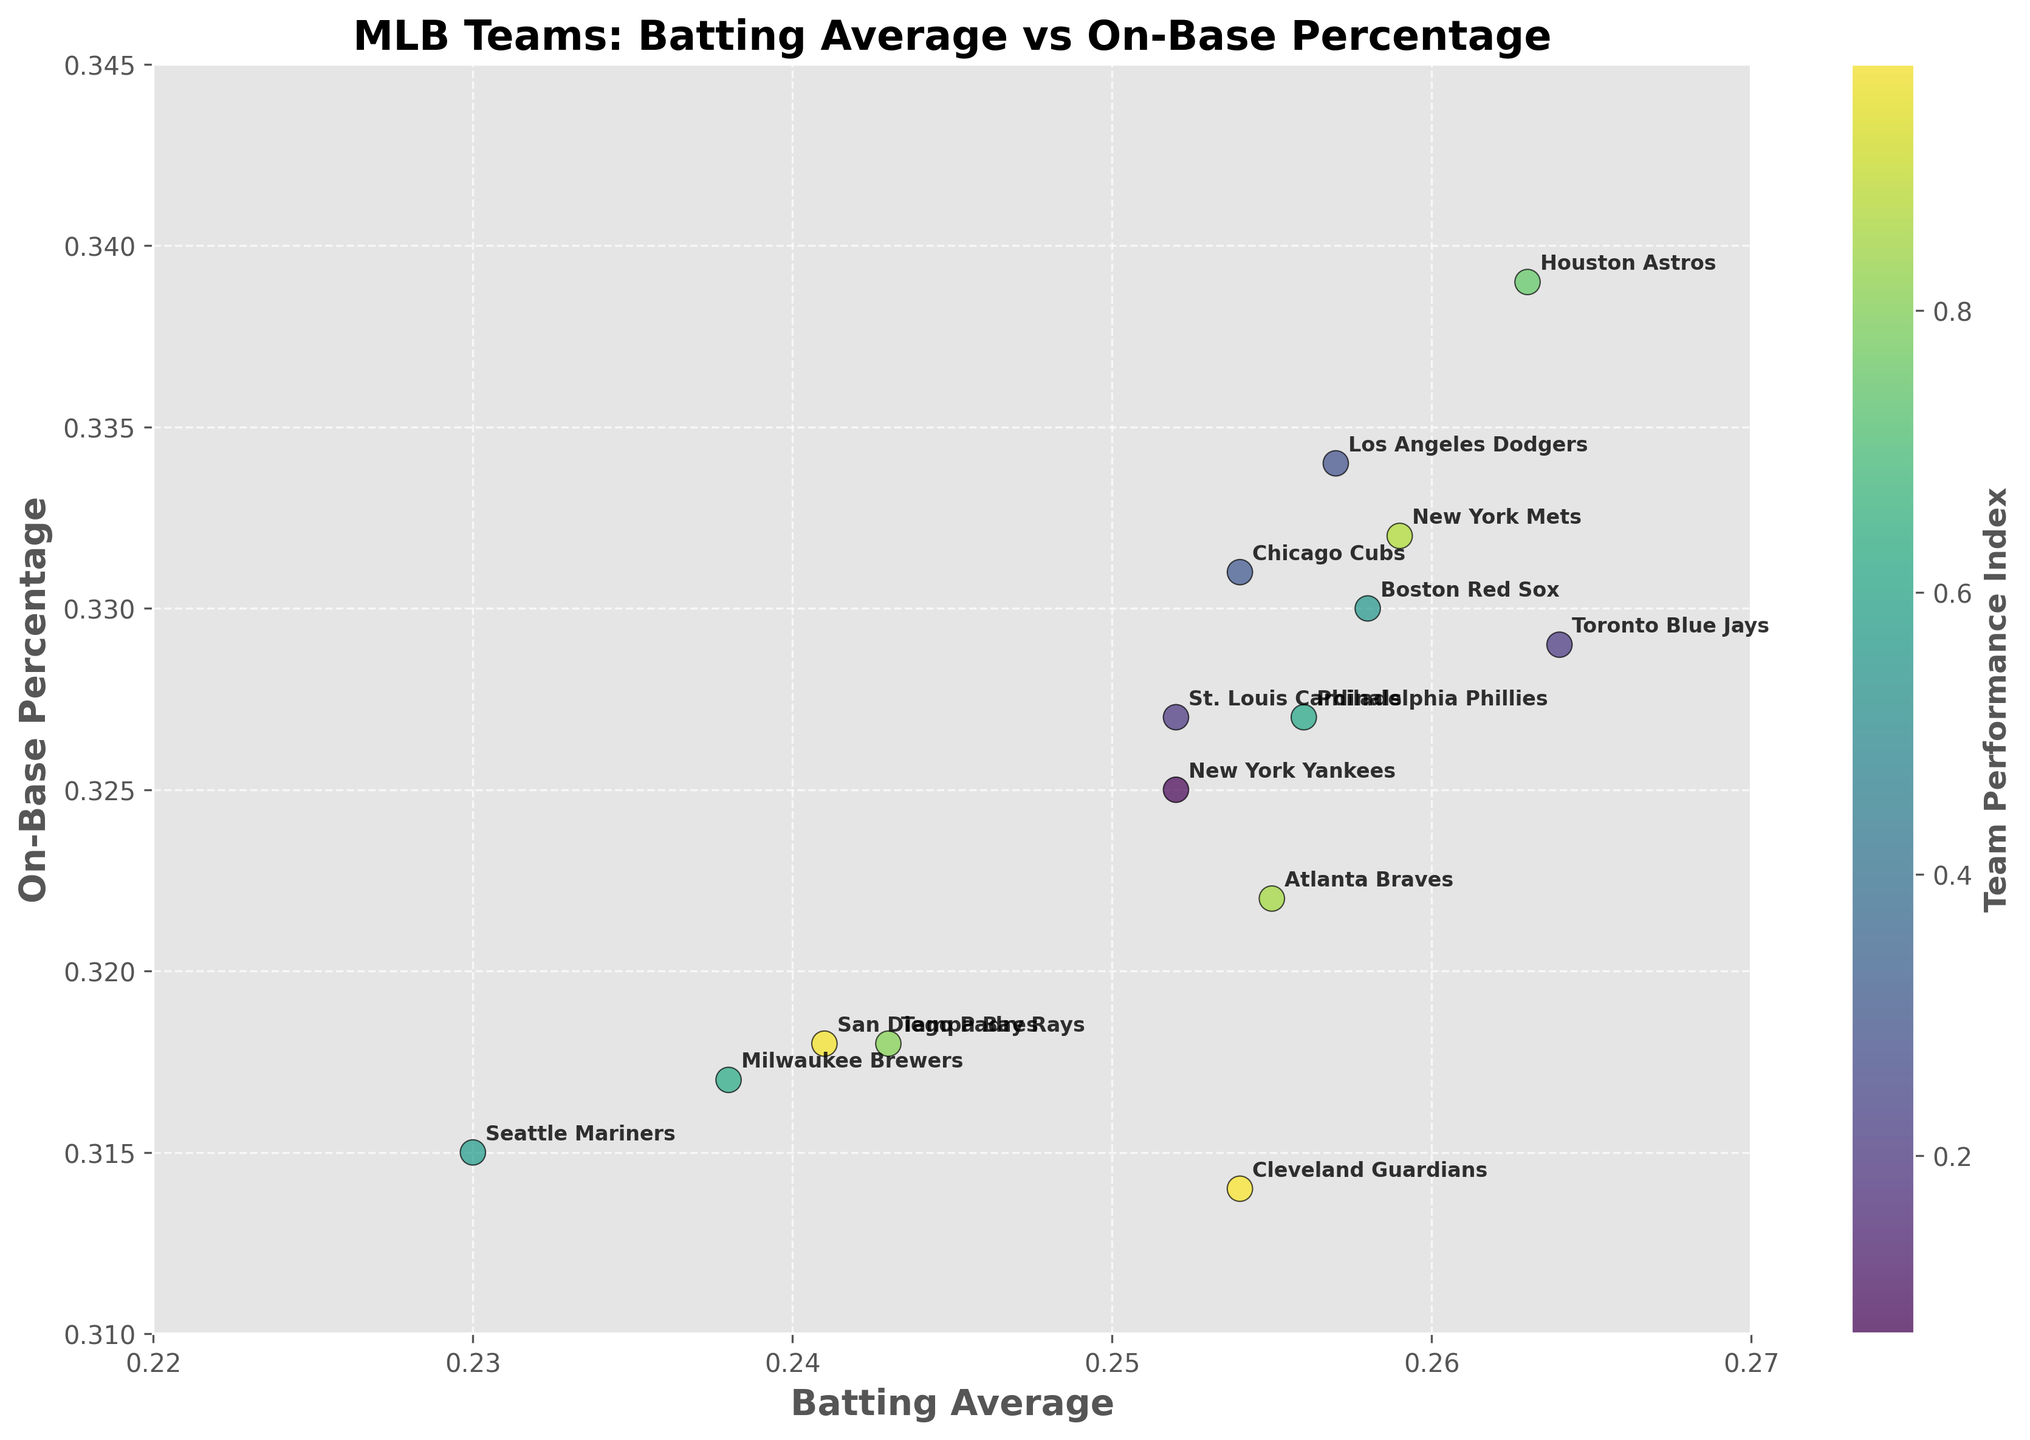What is the title of the figure? The title of the figure is displayed at the top of the plot area. It helps convey what the visual representation is about.
Answer: MLB Teams: Batting Average vs On-Base Percentage What do the x and y axes represent? The labels on the axes provide this information. The x-axis represents Batting Average, and the y-axis represents On-Base Percentage.
Answer: Batting Average and On-Base Percentage Which team has the highest batting average? By looking at the furthest point to the right on the x-axis, we can identify the team with the highest batting average.
Answer: Toronto Blue Jays Which team has the lowest on-base percentage? By examining the lowest point on the y-axis, we can determine the team with the lowest on-base percentage.
Answer: Atlanta Braves How many teams are represented in the plot? The number of unique points or the number of annotations (team names) tells us how many teams are plotted.
Answer: 15 Which team is closest to the average batting average and on-base percentage in the plot? To find this, compare the positions of all points to the center of the data distribution. The New York Yankees appear to be closest to the center.
Answer: New York Yankees Are there more teams with a batting average above 0.25 or below 0.25? Count the number of points to the right of the 0.25 mark on the x-axis and those to the left. There are 10 teams above and 5 below.
Answer: Above 0.25 What is the general trend between batting average and on-base percentage in the plot? By observing the scatter plot, we can see if there is a positive or negative correlation. The general trend is a positive correlation as teams with higher batting averages generally have higher on-base percentages.
Answer: Positive correlation Which two teams have the closest batting averages? Look for points that are closest horizontally on the x-axis. The New York Yankees and St. Louis Cardinals have nearly identical batting averages.
Answer: New York Yankees and St. Louis Cardinals What is the difference in on-base percentage between the Houston Astros and Seattle Mariners? Find the y-values for both teams and subtract the Mariners' value from the Astros’ value: 0.339 - 0.315 = 0.024.
Answer: 0.024 